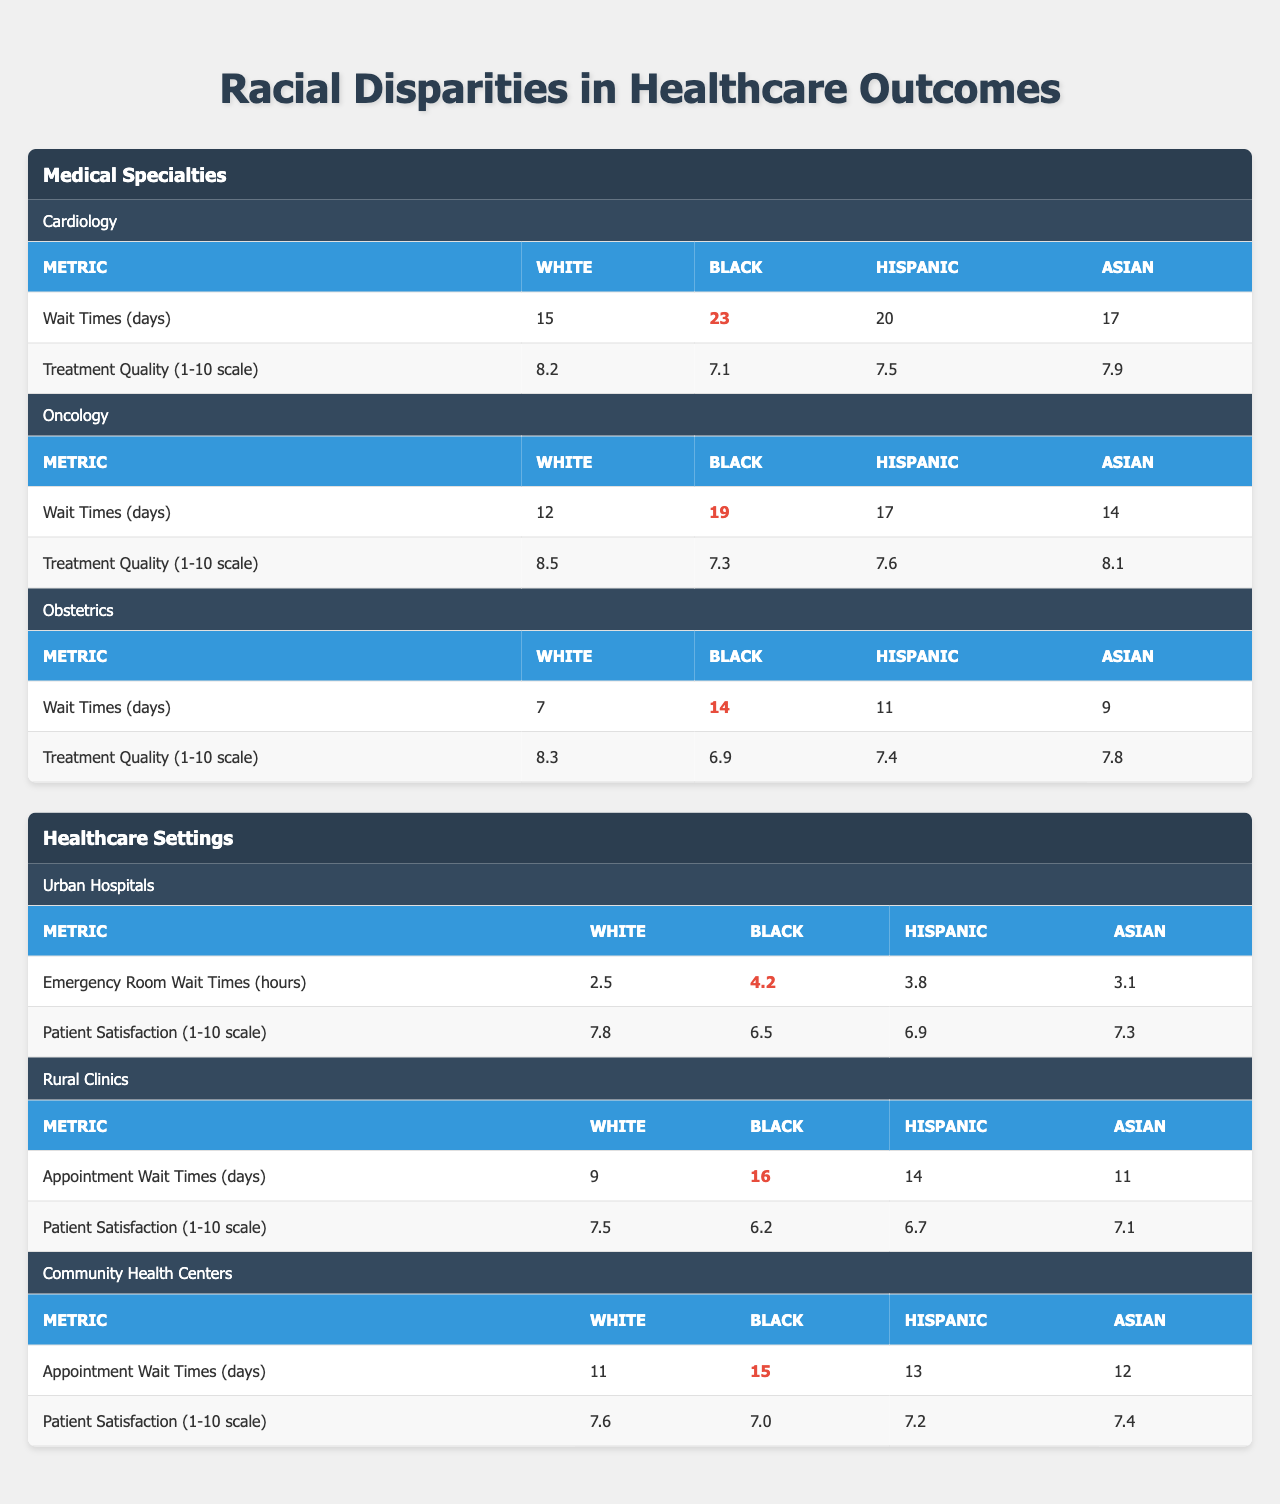What is the wait time for Black patients in Cardiology? The table shows that the wait time for Black patients in the Cardiology specialty is 23 days.
Answer: 23 days What is the treatment quality score for White patients in Oncology? The treatment quality score for White patients in Oncology is 8.5 on a scale of 1 to 10.
Answer: 8.5 Which racial group has the highest wait time for appointments in Rural Clinics? The table indicates that Black patients have the highest wait time for appointments in Rural Clinics at 16 days.
Answer: Black patients What is the difference in emergency room wait times between White and Hispanic patients in Urban Hospitals? For White patients, the wait time is 2.5 hours, and for Hispanic patients, it is 3.8 hours. The difference is 3.8 - 2.5 = 1.3 hours.
Answer: 1.3 hours Which medical specialty shows the largest racial disparity in treatment quality between White and Black patients? In Cardiology, the treatment quality for White patients is 8.2, while for Black patients it is 7.1, making the disparity 8.2 - 7.1 = 1.1. In Oncology, it is 8.5 - 7.3 = 1.2, and in Obstetrics, it is 8.3 - 6.9 = 1.4. Hence, Obstetrics shows the largest disparity at 1.4.
Answer: Obstetrics Is the patient satisfaction score for Black patients in Community Health Centers higher than that in Rural Clinics? The patient satisfaction score for Black patients in Community Health Centers is 7.0 while in Rural Clinics it is 6.2. Since 7.0 > 6.2, the statement is true.
Answer: Yes What is the average wait time for Asian patients across all medical specialties? The wait times for Asian patients are 17 days in Cardiology, 14 days in Oncology, and 9 days in Obstetrics. The average is (17 + 14 + 9) / 3 = 13.33 days.
Answer: 13.33 days How much longer do Black patients wait for appointments in Community Health Centers compared to White patients? The wait time for Black patients in Community Health Centers is 15 days and for White patients, it is 11 days. The difference is 15 - 11 = 4 days.
Answer: 4 days Which healthcare setting has the lowest patient satisfaction score for Black patients? The table shows that in Urban Hospitals, the patient satisfaction score for Black patients is 6.5, which is lower than in Rural Clinics (6.2) and Community Health Centers (7.0). Thus, Rural Clinics have the lowest score.
Answer: Rural Clinics In which specialty do Hispanic patients experience the shortest treatment quality score? Hispanic patients have a treatment quality score of 7.5 in Cardiology, 7.6 in Oncology, and 7.4 in Obstetrics, making Obstetrics the specialty in which they experience the shortest score of 7.4.
Answer: Obstetrics What is the total wait time for Black patients across all specialties? The total wait time for Black patients is 23 days (Cardiology) + 19 days (Oncology) + 14 days (Obstetrics) = 56 days.
Answer: 56 days 